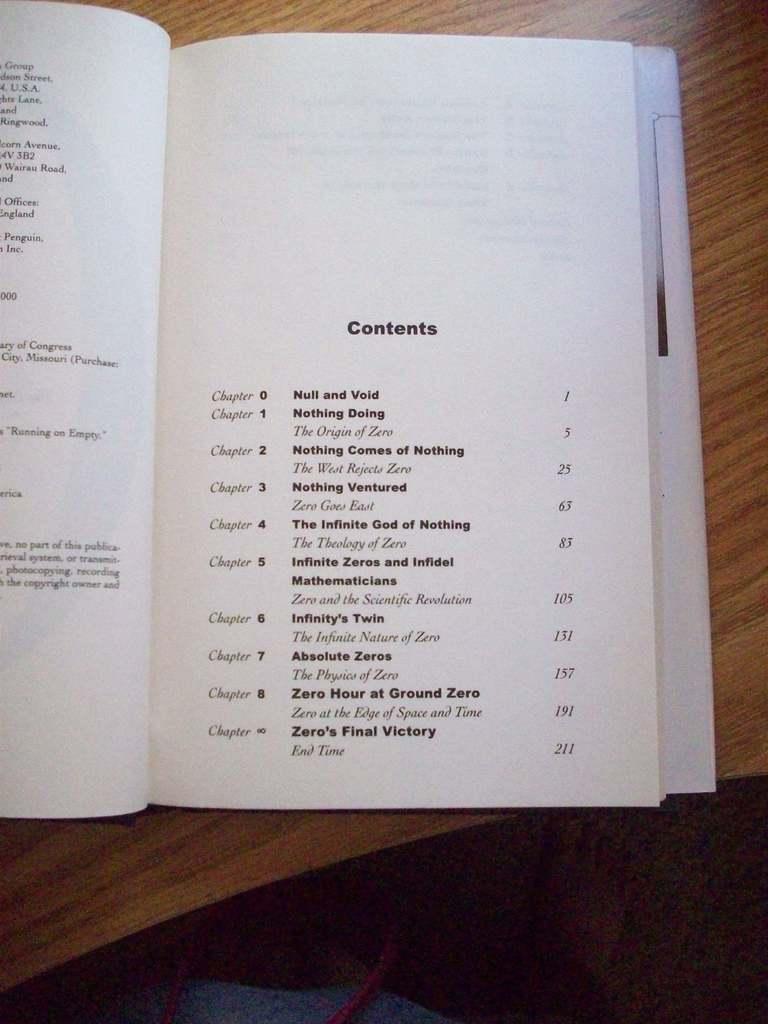Who is zero in this book?
Offer a very short reply. Unanswerable. What is the heading on this page?
Keep it short and to the point. Contents. 